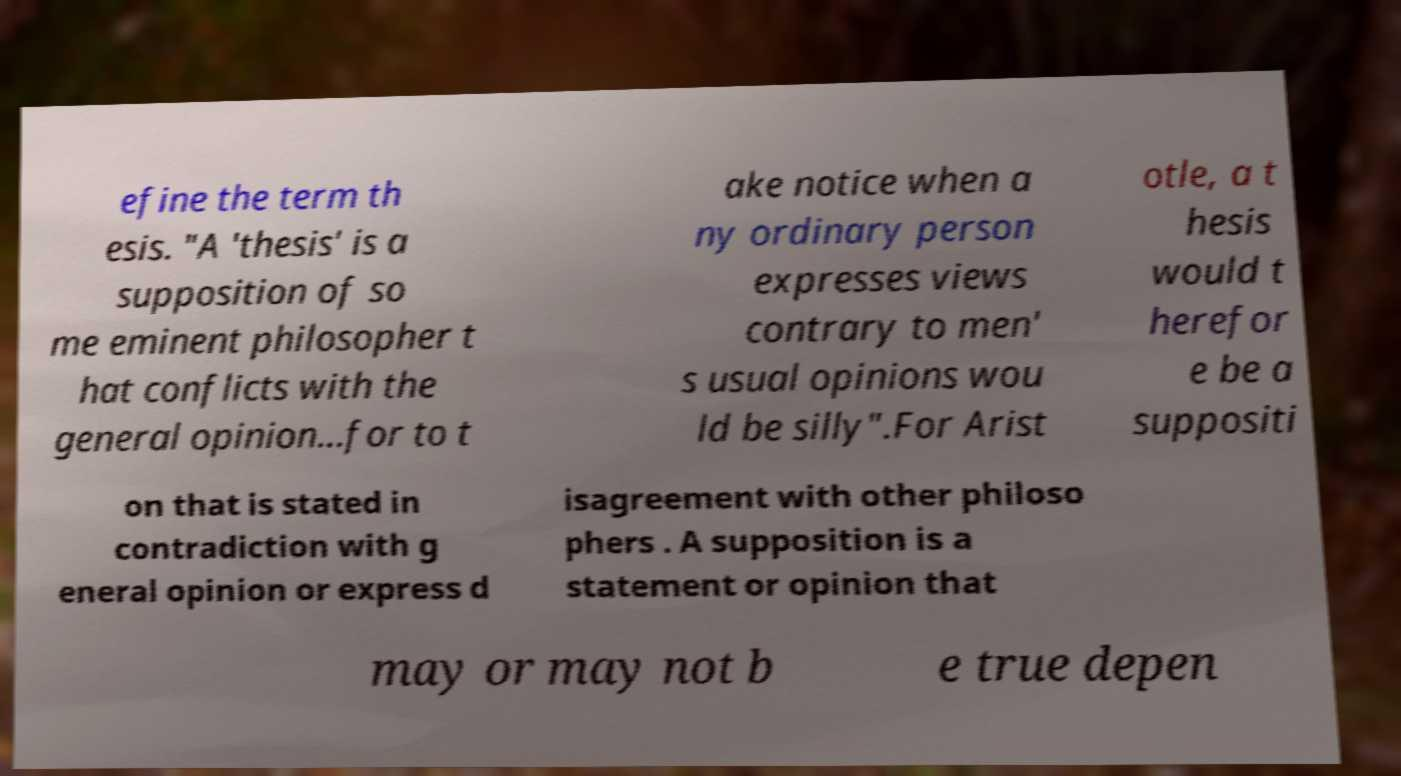Can you read and provide the text displayed in the image?This photo seems to have some interesting text. Can you extract and type it out for me? efine the term th esis. "A 'thesis' is a supposition of so me eminent philosopher t hat conflicts with the general opinion...for to t ake notice when a ny ordinary person expresses views contrary to men' s usual opinions wou ld be silly".For Arist otle, a t hesis would t herefor e be a suppositi on that is stated in contradiction with g eneral opinion or express d isagreement with other philoso phers . A supposition is a statement or opinion that may or may not b e true depen 